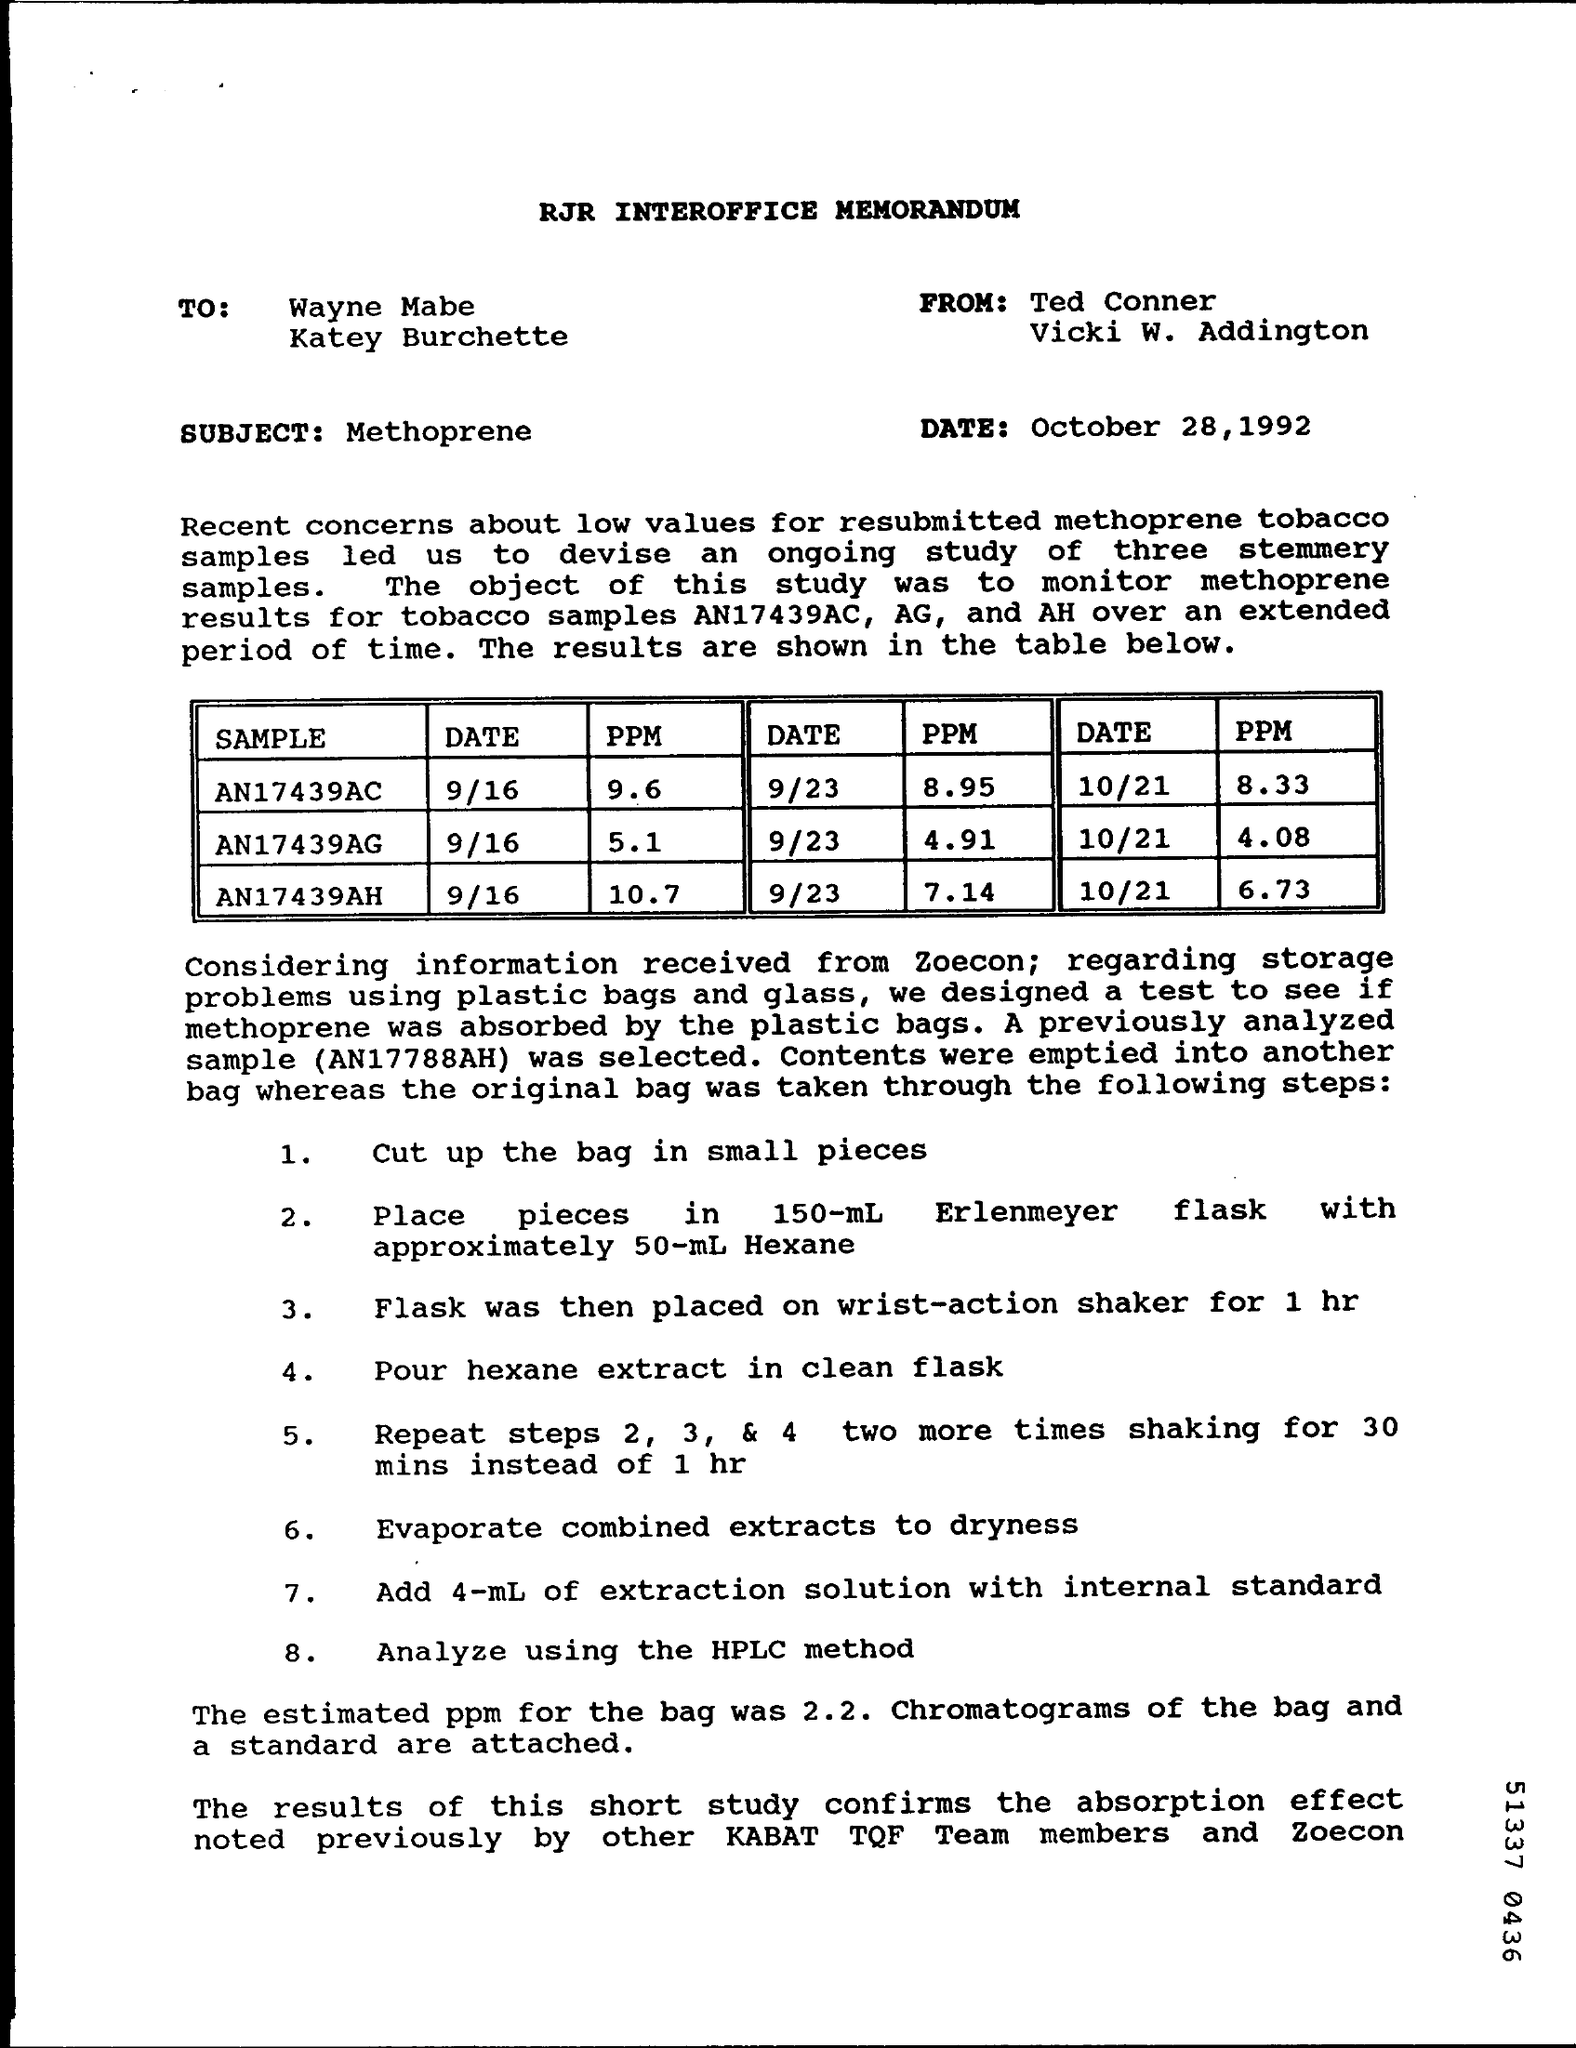What type of documentation is this?
Offer a terse response. RJR INTEROFFICE MEMORANDUM. What is the subject of the document?
Your answer should be compact. Methoprene. What is the estimated ppm for the bag?
Ensure brevity in your answer.  2.2. What was the ppm for sample AN17439AC on 9/16?
Provide a succinct answer. 9.6. 